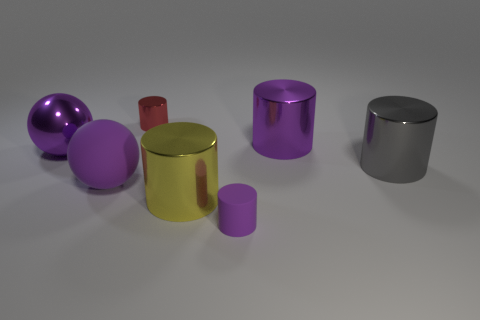Are there fewer large spheres than big red objects?
Keep it short and to the point. No. There is a gray thing that is the same size as the yellow metallic thing; what is its material?
Provide a short and direct response. Metal. Is the color of the big metallic sphere the same as the tiny thing behind the large yellow shiny object?
Your response must be concise. No. Are there fewer shiny things that are behind the large purple matte sphere than large shiny cubes?
Your answer should be very brief. No. How many tiny matte cylinders are there?
Keep it short and to the point. 1. What is the shape of the big thing in front of the big matte ball in front of the tiny red object?
Give a very brief answer. Cylinder. What number of small purple cylinders are behind the small metal cylinder?
Keep it short and to the point. 0. Is the gray object made of the same material as the big cylinder that is to the left of the big purple cylinder?
Make the answer very short. Yes. Are there any gray cylinders of the same size as the yellow metal cylinder?
Offer a terse response. Yes. Is the number of small purple rubber cylinders that are to the right of the purple rubber cylinder the same as the number of big yellow metal objects?
Ensure brevity in your answer.  No. 